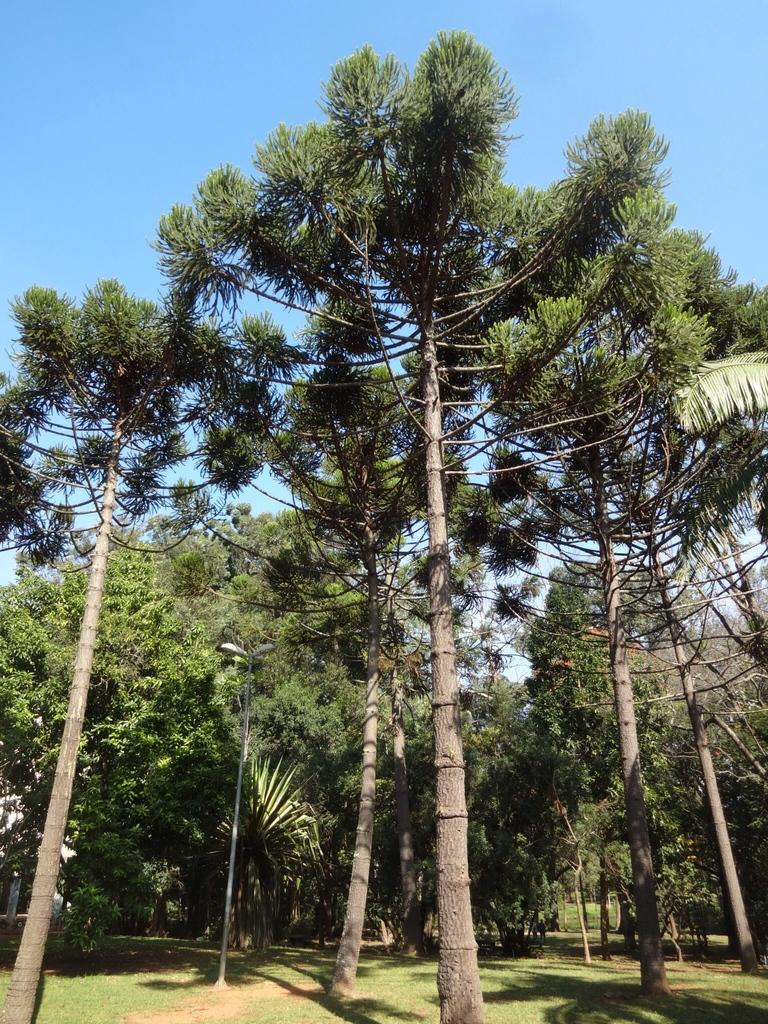What type of vegetation is visible in the image? There are trees in the image. What type of man-made structure can be seen in the image? There is a light pole in the image. What part of the natural environment is visible in the image? The sky is visible in the image. What holiday is being celebrated in the image? There is no indication of a holiday being celebrated in the image. Can you see any friends kissing in the image? There is no indication of friends or any kissing in the image. 